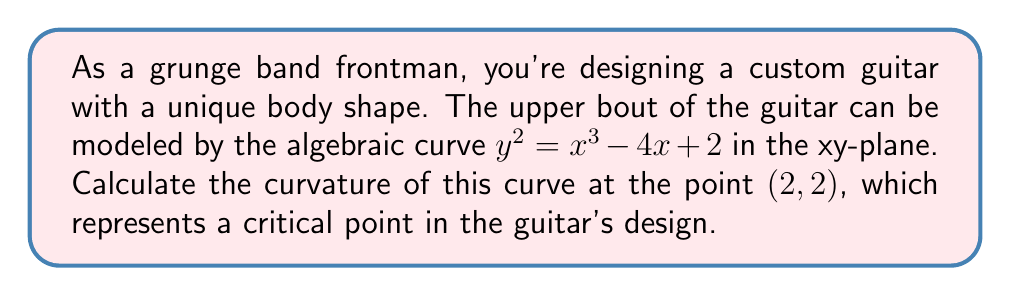Provide a solution to this math problem. Let's approach this step-by-step:

1) The curvature $\kappa$ of a curve $y = f(x)$ at a point $(x, y)$ is given by:

   $$\kappa = \frac{|y''|}{(1 + (y')^2)^{3/2}}$$

   where $y'$ and $y''$ are the first and second derivatives of $y$ with respect to $x$.

2) Our curve is implicitly defined. Let's differentiate it implicitly:
   
   $y^2 = x^3 - 4x + 2$
   
   Differentiating both sides with respect to $x$:
   
   $$2y\frac{dy}{dx} = 3x^2 - 4$$
   
   $$y' = \frac{3x^2 - 4}{2y}$$

3) Differentiating again:

   $$y'' = \frac{(6x)(2y) - (3x^2 - 4)(2y')}{(2y)^2}$$

4) At the point $(2, 2)$, we can calculate $y'$:

   $$y'_{(2,2)} = \frac{3(2)^2 - 4}{2(2)} = \frac{8}{4} = 2$$

5) Now let's calculate $y''$ at $(2, 2)$:

   $$y''_{(2,2)} = \frac{(6(2))(2(2)) - (3(2)^2 - 4)(2(2))}{(2(2))^2} = \frac{24 - 20}{16} = \frac{1}{4}$$

6) Now we can plug these values into our curvature formula:

   $$\kappa = \frac{|\frac{1}{4}|}{(1 + (2)^2)^{3/2}} = \frac{1/4}{(1 + 4)^{3/2}} = \frac{1/4}{5^{3/2}}$$

7) Simplifying:

   $$\kappa = \frac{1}{4 \cdot 5^{3/2}} = \frac{1}{4 \cdot 5\sqrt{5}}$$
Answer: $\frac{1}{20\sqrt{5}}$ 